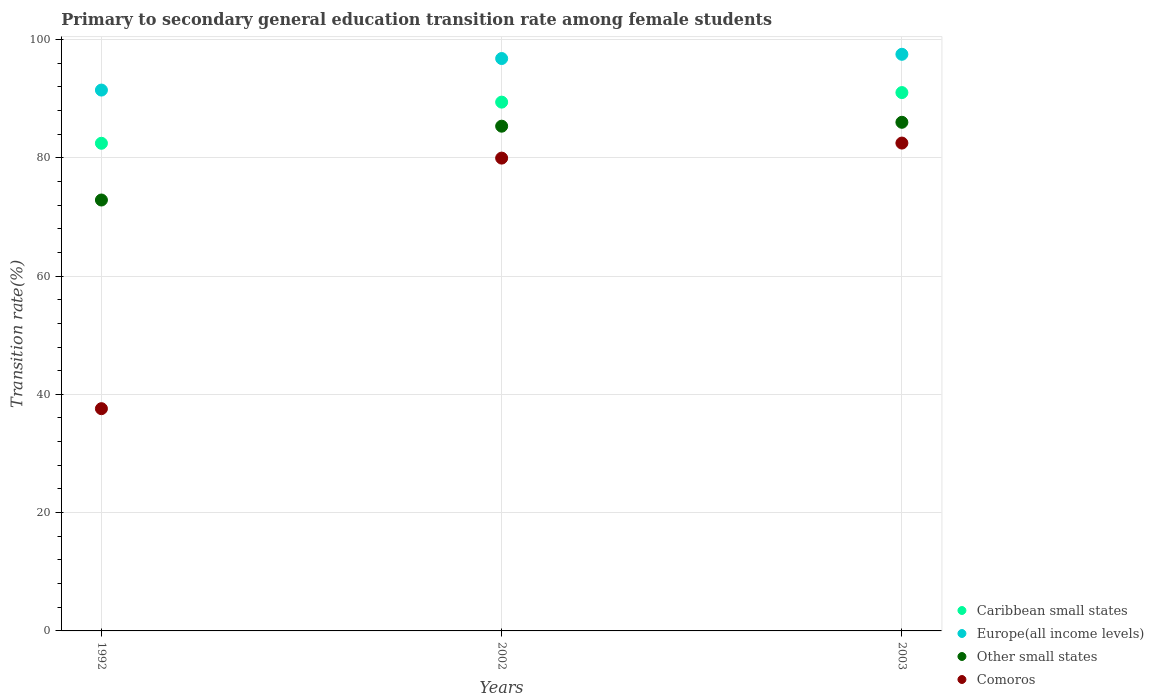How many different coloured dotlines are there?
Provide a short and direct response. 4. What is the transition rate in Other small states in 2002?
Your answer should be compact. 85.33. Across all years, what is the maximum transition rate in Caribbean small states?
Give a very brief answer. 91.01. Across all years, what is the minimum transition rate in Caribbean small states?
Offer a very short reply. 82.44. What is the total transition rate in Caribbean small states in the graph?
Provide a succinct answer. 262.85. What is the difference between the transition rate in Caribbean small states in 1992 and that in 2003?
Keep it short and to the point. -8.57. What is the difference between the transition rate in Comoros in 2002 and the transition rate in Europe(all income levels) in 1992?
Provide a short and direct response. -11.5. What is the average transition rate in Europe(all income levels) per year?
Make the answer very short. 95.23. In the year 1992, what is the difference between the transition rate in Other small states and transition rate in Comoros?
Offer a very short reply. 35.28. In how many years, is the transition rate in Caribbean small states greater than 16 %?
Your response must be concise. 3. What is the ratio of the transition rate in Europe(all income levels) in 1992 to that in 2002?
Ensure brevity in your answer.  0.94. What is the difference between the highest and the second highest transition rate in Caribbean small states?
Provide a short and direct response. 1.61. What is the difference between the highest and the lowest transition rate in Caribbean small states?
Offer a very short reply. 8.57. Is the transition rate in Caribbean small states strictly greater than the transition rate in Other small states over the years?
Keep it short and to the point. Yes. How many dotlines are there?
Offer a terse response. 4. How many years are there in the graph?
Your answer should be compact. 3. What is the difference between two consecutive major ticks on the Y-axis?
Your answer should be compact. 20. Does the graph contain any zero values?
Keep it short and to the point. No. Does the graph contain grids?
Offer a very short reply. Yes. How many legend labels are there?
Provide a succinct answer. 4. What is the title of the graph?
Offer a very short reply. Primary to secondary general education transition rate among female students. Does "Trinidad and Tobago" appear as one of the legend labels in the graph?
Your response must be concise. No. What is the label or title of the Y-axis?
Offer a very short reply. Transition rate(%). What is the Transition rate(%) of Caribbean small states in 1992?
Offer a very short reply. 82.44. What is the Transition rate(%) in Europe(all income levels) in 1992?
Your response must be concise. 91.44. What is the Transition rate(%) in Other small states in 1992?
Provide a succinct answer. 72.85. What is the Transition rate(%) of Comoros in 1992?
Offer a very short reply. 37.57. What is the Transition rate(%) in Caribbean small states in 2002?
Your answer should be very brief. 89.4. What is the Transition rate(%) of Europe(all income levels) in 2002?
Your response must be concise. 96.77. What is the Transition rate(%) of Other small states in 2002?
Provide a succinct answer. 85.33. What is the Transition rate(%) in Comoros in 2002?
Ensure brevity in your answer.  79.93. What is the Transition rate(%) of Caribbean small states in 2003?
Your response must be concise. 91.01. What is the Transition rate(%) of Europe(all income levels) in 2003?
Give a very brief answer. 97.49. What is the Transition rate(%) of Other small states in 2003?
Your response must be concise. 85.99. What is the Transition rate(%) in Comoros in 2003?
Your response must be concise. 82.48. Across all years, what is the maximum Transition rate(%) of Caribbean small states?
Provide a succinct answer. 91.01. Across all years, what is the maximum Transition rate(%) of Europe(all income levels)?
Ensure brevity in your answer.  97.49. Across all years, what is the maximum Transition rate(%) of Other small states?
Ensure brevity in your answer.  85.99. Across all years, what is the maximum Transition rate(%) in Comoros?
Offer a very short reply. 82.48. Across all years, what is the minimum Transition rate(%) in Caribbean small states?
Offer a very short reply. 82.44. Across all years, what is the minimum Transition rate(%) in Europe(all income levels)?
Offer a very short reply. 91.44. Across all years, what is the minimum Transition rate(%) of Other small states?
Provide a short and direct response. 72.85. Across all years, what is the minimum Transition rate(%) in Comoros?
Ensure brevity in your answer.  37.57. What is the total Transition rate(%) in Caribbean small states in the graph?
Make the answer very short. 262.85. What is the total Transition rate(%) of Europe(all income levels) in the graph?
Offer a terse response. 285.69. What is the total Transition rate(%) in Other small states in the graph?
Your response must be concise. 244.17. What is the total Transition rate(%) of Comoros in the graph?
Your answer should be very brief. 199.99. What is the difference between the Transition rate(%) of Caribbean small states in 1992 and that in 2002?
Keep it short and to the point. -6.96. What is the difference between the Transition rate(%) of Europe(all income levels) in 1992 and that in 2002?
Your answer should be compact. -5.33. What is the difference between the Transition rate(%) of Other small states in 1992 and that in 2002?
Give a very brief answer. -12.48. What is the difference between the Transition rate(%) of Comoros in 1992 and that in 2002?
Ensure brevity in your answer.  -42.36. What is the difference between the Transition rate(%) of Caribbean small states in 1992 and that in 2003?
Ensure brevity in your answer.  -8.57. What is the difference between the Transition rate(%) of Europe(all income levels) in 1992 and that in 2003?
Ensure brevity in your answer.  -6.05. What is the difference between the Transition rate(%) in Other small states in 1992 and that in 2003?
Provide a short and direct response. -13.14. What is the difference between the Transition rate(%) in Comoros in 1992 and that in 2003?
Your answer should be very brief. -44.9. What is the difference between the Transition rate(%) in Caribbean small states in 2002 and that in 2003?
Ensure brevity in your answer.  -1.61. What is the difference between the Transition rate(%) of Europe(all income levels) in 2002 and that in 2003?
Offer a terse response. -0.72. What is the difference between the Transition rate(%) in Other small states in 2002 and that in 2003?
Make the answer very short. -0.66. What is the difference between the Transition rate(%) of Comoros in 2002 and that in 2003?
Offer a very short reply. -2.54. What is the difference between the Transition rate(%) in Caribbean small states in 1992 and the Transition rate(%) in Europe(all income levels) in 2002?
Offer a very short reply. -14.33. What is the difference between the Transition rate(%) in Caribbean small states in 1992 and the Transition rate(%) in Other small states in 2002?
Provide a succinct answer. -2.89. What is the difference between the Transition rate(%) in Caribbean small states in 1992 and the Transition rate(%) in Comoros in 2002?
Offer a terse response. 2.51. What is the difference between the Transition rate(%) of Europe(all income levels) in 1992 and the Transition rate(%) of Other small states in 2002?
Make the answer very short. 6.11. What is the difference between the Transition rate(%) in Europe(all income levels) in 1992 and the Transition rate(%) in Comoros in 2002?
Give a very brief answer. 11.5. What is the difference between the Transition rate(%) in Other small states in 1992 and the Transition rate(%) in Comoros in 2002?
Give a very brief answer. -7.08. What is the difference between the Transition rate(%) in Caribbean small states in 1992 and the Transition rate(%) in Europe(all income levels) in 2003?
Ensure brevity in your answer.  -15.04. What is the difference between the Transition rate(%) in Caribbean small states in 1992 and the Transition rate(%) in Other small states in 2003?
Your answer should be very brief. -3.55. What is the difference between the Transition rate(%) in Caribbean small states in 1992 and the Transition rate(%) in Comoros in 2003?
Give a very brief answer. -0.03. What is the difference between the Transition rate(%) in Europe(all income levels) in 1992 and the Transition rate(%) in Other small states in 2003?
Make the answer very short. 5.45. What is the difference between the Transition rate(%) in Europe(all income levels) in 1992 and the Transition rate(%) in Comoros in 2003?
Provide a succinct answer. 8.96. What is the difference between the Transition rate(%) of Other small states in 1992 and the Transition rate(%) of Comoros in 2003?
Make the answer very short. -9.63. What is the difference between the Transition rate(%) of Caribbean small states in 2002 and the Transition rate(%) of Europe(all income levels) in 2003?
Ensure brevity in your answer.  -8.09. What is the difference between the Transition rate(%) of Caribbean small states in 2002 and the Transition rate(%) of Other small states in 2003?
Offer a terse response. 3.41. What is the difference between the Transition rate(%) of Caribbean small states in 2002 and the Transition rate(%) of Comoros in 2003?
Provide a short and direct response. 6.92. What is the difference between the Transition rate(%) of Europe(all income levels) in 2002 and the Transition rate(%) of Other small states in 2003?
Make the answer very short. 10.78. What is the difference between the Transition rate(%) of Europe(all income levels) in 2002 and the Transition rate(%) of Comoros in 2003?
Your answer should be very brief. 14.29. What is the difference between the Transition rate(%) in Other small states in 2002 and the Transition rate(%) in Comoros in 2003?
Make the answer very short. 2.85. What is the average Transition rate(%) of Caribbean small states per year?
Offer a terse response. 87.62. What is the average Transition rate(%) in Europe(all income levels) per year?
Provide a succinct answer. 95.23. What is the average Transition rate(%) in Other small states per year?
Give a very brief answer. 81.39. What is the average Transition rate(%) in Comoros per year?
Make the answer very short. 66.66. In the year 1992, what is the difference between the Transition rate(%) in Caribbean small states and Transition rate(%) in Europe(all income levels)?
Keep it short and to the point. -8.99. In the year 1992, what is the difference between the Transition rate(%) of Caribbean small states and Transition rate(%) of Other small states?
Offer a terse response. 9.59. In the year 1992, what is the difference between the Transition rate(%) of Caribbean small states and Transition rate(%) of Comoros?
Provide a short and direct response. 44.87. In the year 1992, what is the difference between the Transition rate(%) in Europe(all income levels) and Transition rate(%) in Other small states?
Your response must be concise. 18.59. In the year 1992, what is the difference between the Transition rate(%) in Europe(all income levels) and Transition rate(%) in Comoros?
Give a very brief answer. 53.86. In the year 1992, what is the difference between the Transition rate(%) of Other small states and Transition rate(%) of Comoros?
Provide a succinct answer. 35.28. In the year 2002, what is the difference between the Transition rate(%) of Caribbean small states and Transition rate(%) of Europe(all income levels)?
Your response must be concise. -7.37. In the year 2002, what is the difference between the Transition rate(%) of Caribbean small states and Transition rate(%) of Other small states?
Your answer should be very brief. 4.07. In the year 2002, what is the difference between the Transition rate(%) in Caribbean small states and Transition rate(%) in Comoros?
Provide a succinct answer. 9.46. In the year 2002, what is the difference between the Transition rate(%) in Europe(all income levels) and Transition rate(%) in Other small states?
Keep it short and to the point. 11.44. In the year 2002, what is the difference between the Transition rate(%) of Europe(all income levels) and Transition rate(%) of Comoros?
Keep it short and to the point. 16.84. In the year 2002, what is the difference between the Transition rate(%) in Other small states and Transition rate(%) in Comoros?
Offer a terse response. 5.4. In the year 2003, what is the difference between the Transition rate(%) of Caribbean small states and Transition rate(%) of Europe(all income levels)?
Make the answer very short. -6.47. In the year 2003, what is the difference between the Transition rate(%) of Caribbean small states and Transition rate(%) of Other small states?
Give a very brief answer. 5.02. In the year 2003, what is the difference between the Transition rate(%) of Caribbean small states and Transition rate(%) of Comoros?
Offer a very short reply. 8.54. In the year 2003, what is the difference between the Transition rate(%) of Europe(all income levels) and Transition rate(%) of Other small states?
Your answer should be compact. 11.5. In the year 2003, what is the difference between the Transition rate(%) of Europe(all income levels) and Transition rate(%) of Comoros?
Offer a very short reply. 15.01. In the year 2003, what is the difference between the Transition rate(%) in Other small states and Transition rate(%) in Comoros?
Your answer should be very brief. 3.51. What is the ratio of the Transition rate(%) in Caribbean small states in 1992 to that in 2002?
Provide a succinct answer. 0.92. What is the ratio of the Transition rate(%) in Europe(all income levels) in 1992 to that in 2002?
Your answer should be compact. 0.94. What is the ratio of the Transition rate(%) in Other small states in 1992 to that in 2002?
Keep it short and to the point. 0.85. What is the ratio of the Transition rate(%) of Comoros in 1992 to that in 2002?
Your answer should be compact. 0.47. What is the ratio of the Transition rate(%) of Caribbean small states in 1992 to that in 2003?
Your response must be concise. 0.91. What is the ratio of the Transition rate(%) in Europe(all income levels) in 1992 to that in 2003?
Keep it short and to the point. 0.94. What is the ratio of the Transition rate(%) in Other small states in 1992 to that in 2003?
Make the answer very short. 0.85. What is the ratio of the Transition rate(%) in Comoros in 1992 to that in 2003?
Give a very brief answer. 0.46. What is the ratio of the Transition rate(%) in Caribbean small states in 2002 to that in 2003?
Ensure brevity in your answer.  0.98. What is the ratio of the Transition rate(%) of Other small states in 2002 to that in 2003?
Your answer should be very brief. 0.99. What is the ratio of the Transition rate(%) of Comoros in 2002 to that in 2003?
Your response must be concise. 0.97. What is the difference between the highest and the second highest Transition rate(%) of Caribbean small states?
Make the answer very short. 1.61. What is the difference between the highest and the second highest Transition rate(%) in Europe(all income levels)?
Keep it short and to the point. 0.72. What is the difference between the highest and the second highest Transition rate(%) in Other small states?
Provide a succinct answer. 0.66. What is the difference between the highest and the second highest Transition rate(%) of Comoros?
Provide a short and direct response. 2.54. What is the difference between the highest and the lowest Transition rate(%) of Caribbean small states?
Your answer should be compact. 8.57. What is the difference between the highest and the lowest Transition rate(%) of Europe(all income levels)?
Provide a succinct answer. 6.05. What is the difference between the highest and the lowest Transition rate(%) of Other small states?
Give a very brief answer. 13.14. What is the difference between the highest and the lowest Transition rate(%) in Comoros?
Your answer should be compact. 44.9. 